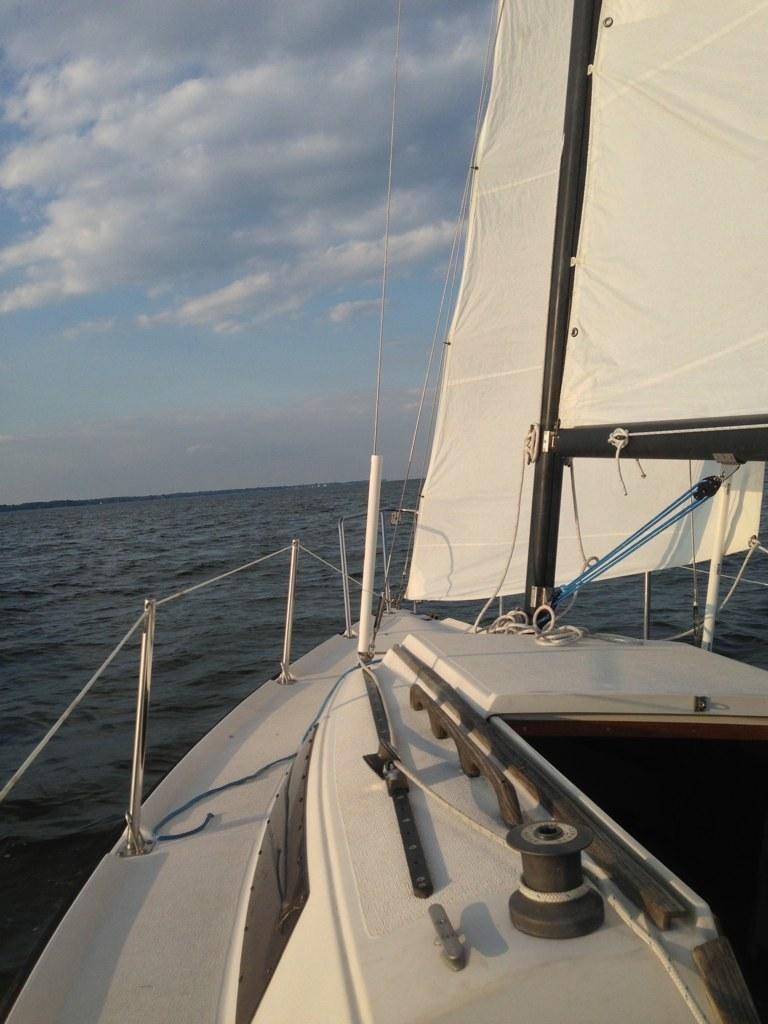What is the main subject of the image? There is a ship in the image. Where is the ship located? The ship is on water. What else can be seen in the image besides the ship? The sky is visible in the image. Can you describe the sky in the image? There are clouds in the sky. What type of list can be seen hanging from the ship's mast in the image? There is no list present in the image; it only features a ship on water with clouds in the sky. 